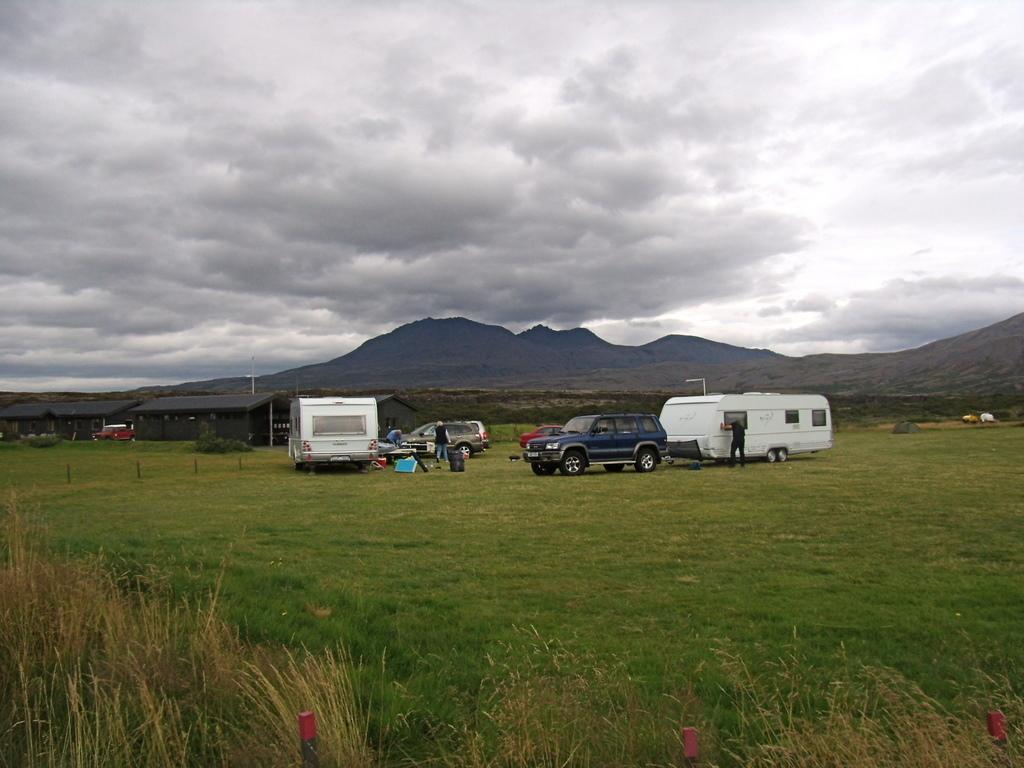Describe this image in one or two sentences. In this image there is a ground. On the ground there are vehicles like cars and trolleys. On the left side there are buildings on the ground. At the bottom there is grass. In the background there are hills. At the top there is the sky. There are few persons standing beside the vehicles. 